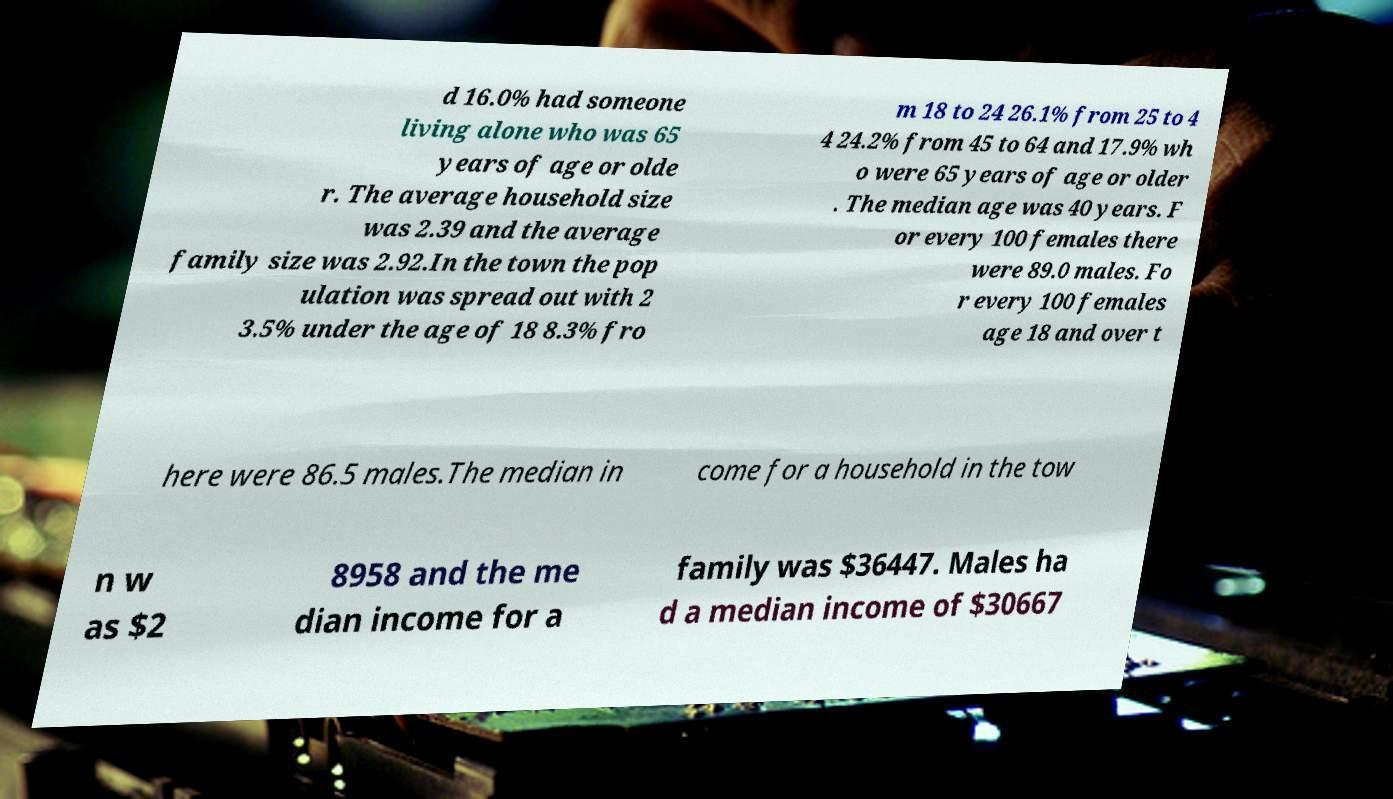Please read and relay the text visible in this image. What does it say? d 16.0% had someone living alone who was 65 years of age or olde r. The average household size was 2.39 and the average family size was 2.92.In the town the pop ulation was spread out with 2 3.5% under the age of 18 8.3% fro m 18 to 24 26.1% from 25 to 4 4 24.2% from 45 to 64 and 17.9% wh o were 65 years of age or older . The median age was 40 years. F or every 100 females there were 89.0 males. Fo r every 100 females age 18 and over t here were 86.5 males.The median in come for a household in the tow n w as $2 8958 and the me dian income for a family was $36447. Males ha d a median income of $30667 